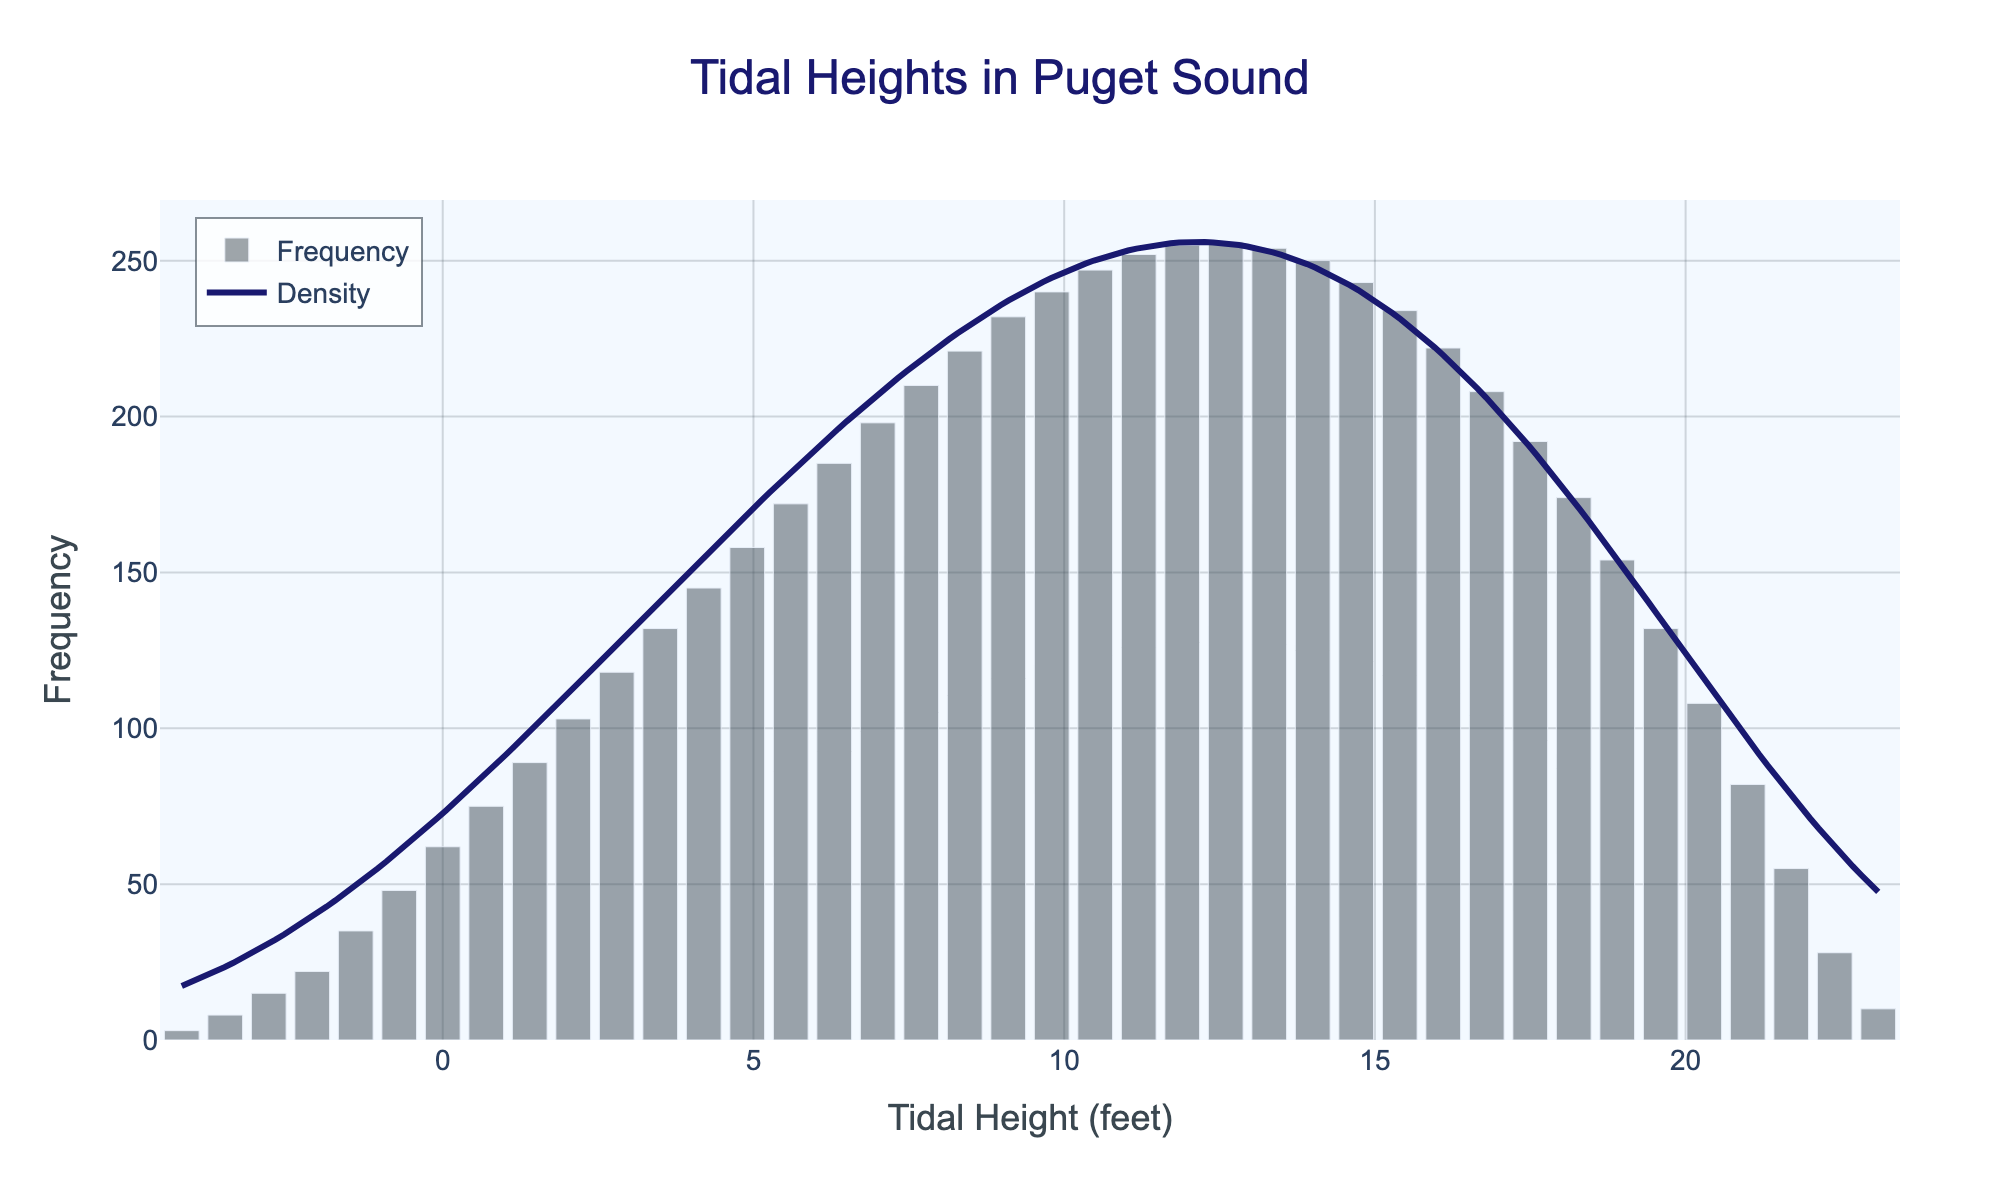What is the title of the plot? The title of the plot is located at the top center of the figure. It is 'Tidal Heights in Puget Sound'.
Answer: 'Tidal Heights in Puget Sound' What is the x-axis title in the figure? The x-axis title can be found below the horizontal axis and is labeled as 'Tidal Height (feet)'.
Answer: 'Tidal Height (feet)' How high is the highest frequency bar in the histogram? The tallest bar in the histogram corresponds to a frequency value at its peak, which is 256. This occurs around a tidal height of 12.6 feet.
Answer: 256 At approximately which tidal height does the KDE curve peak? The KDE (density) curve reaches its peak at the tidal height where the curve is highest, which is around 12.6 feet.
Answer: 12.6 feet Which tidal height has the lowest frequency? To find the lowest frequency, look for the shortest bar in the histogram, which corresponds to a tidal height of -4.2 feet with a frequency of 3.
Answer: -4.2 feet Is there any tidal height that has zero frequency? By examining all the bars in the histogram, you can observe that none of the tidal heights have a zero frequency as each bar has a positive height.
Answer: No What are the upper and lower bounds of tidal heights on the x-axis? The x-axis of the histogram ranges from the lowest to the highest tidal height values shown in the data, which are -4.2 feet and 23.1 feet, respectively.
Answer: -4.2 feet and 23.1 feet What is the frequency of tidal heights around 7.0 feet? Locate the bar closest to the tidal height of 7.0 feet; the frequency for this height is 198.
Answer: 198 How does the frequency at 11.2 feet compare to the frequency at 14.0 feet? The frequency at 11.2 feet is 252, while at 14.0 feet it is 250. Hence, the frequency at 11.2 feet is slightly higher than 14.0 feet.
Answer: 252 vs 250 What is the overall trend in tidal height frequency as the tidal height increases? Generally, the frequency increases until it peaks around the mid-tidal heights (approximately 12.6 feet) and then gradually decreases as the tidal height continues to rise beyond this point.
Answer: Increase then decrease 